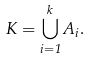Convert formula to latex. <formula><loc_0><loc_0><loc_500><loc_500>K = \bigcup _ { i = 1 } ^ { k } A _ { i } .</formula> 